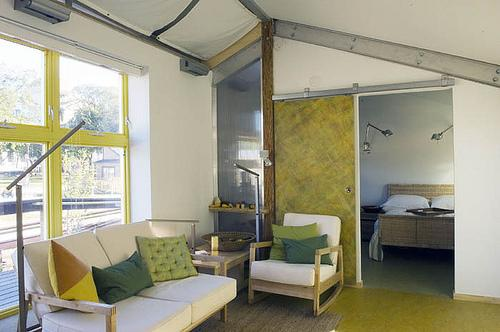Write a description of the image using polite language. This lovely image showcases a cozy interior with a charming white chair adorned with green cushions, a wicker headboard bed, and an elegant wooden rocking chair by a window with a yellow frame. Mention a unique feature of the image. A unique feature of the image is the yellow-painted window frame visible in the scene. In a simple sentence, state the primary object in the image. The primary object in the image is a white chair with green cushions. List the main pieces of furniture visible in the image. 3. Wooden rocking chair State the type of door and its condition in the image. The door is a green and brown sliding door to the bedroom, which appears to be open. Write a description of the image with informal language. Check out this cool pic of a room with a white chair and green cushions, a bed with a wicker headboard, and a wooden rocking chair next to a yellow-framed window. Compose a sentence describing the overall atmosphere of the room in the image. The room in the image has a warm and inviting atmosphere, with soft colors and comfortable furniture. Provide a brief overview of the main features of the image. The image features a white chair with green cushions, a bed with a wicker headboard, a wooden rocking chair, a window with a yellow frame, and a sliding door with green and brown colors. Describe the bed in the image and its surroundings. The bed has a tan wicker headboard and white pillows, with two hanging lights above it, and is situated near a window with a yellow-painted frame. Provide a detailed description of the chair in the image. The chair is white with green square pillows on it, featuring a wooden frame, thin wooden armrests, a white bottom seat cushion, and a white back seat cushion. 